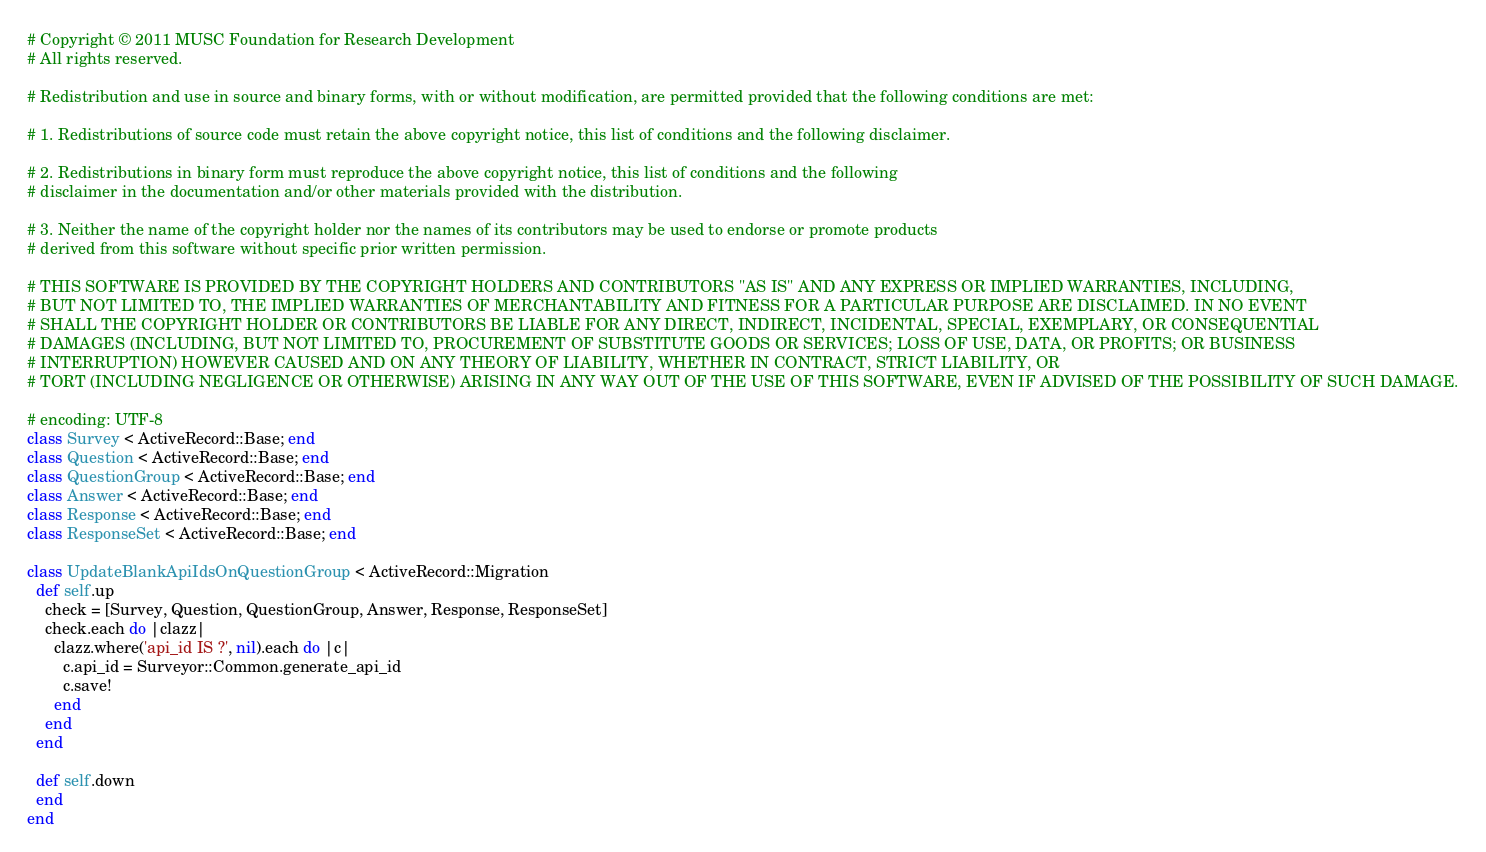<code> <loc_0><loc_0><loc_500><loc_500><_Ruby_># Copyright © 2011 MUSC Foundation for Research Development
# All rights reserved.

# Redistribution and use in source and binary forms, with or without modification, are permitted provided that the following conditions are met:

# 1. Redistributions of source code must retain the above copyright notice, this list of conditions and the following disclaimer.

# 2. Redistributions in binary form must reproduce the above copyright notice, this list of conditions and the following
# disclaimer in the documentation and/or other materials provided with the distribution.

# 3. Neither the name of the copyright holder nor the names of its contributors may be used to endorse or promote products
# derived from this software without specific prior written permission.

# THIS SOFTWARE IS PROVIDED BY THE COPYRIGHT HOLDERS AND CONTRIBUTORS "AS IS" AND ANY EXPRESS OR IMPLIED WARRANTIES, INCLUDING,
# BUT NOT LIMITED TO, THE IMPLIED WARRANTIES OF MERCHANTABILITY AND FITNESS FOR A PARTICULAR PURPOSE ARE DISCLAIMED. IN NO EVENT
# SHALL THE COPYRIGHT HOLDER OR CONTRIBUTORS BE LIABLE FOR ANY DIRECT, INDIRECT, INCIDENTAL, SPECIAL, EXEMPLARY, OR CONSEQUENTIAL
# DAMAGES (INCLUDING, BUT NOT LIMITED TO, PROCUREMENT OF SUBSTITUTE GOODS OR SERVICES; LOSS OF USE, DATA, OR PROFITS; OR BUSINESS
# INTERRUPTION) HOWEVER CAUSED AND ON ANY THEORY OF LIABILITY, WHETHER IN CONTRACT, STRICT LIABILITY, OR
# TORT (INCLUDING NEGLIGENCE OR OTHERWISE) ARISING IN ANY WAY OUT OF THE USE OF THIS SOFTWARE, EVEN IF ADVISED OF THE POSSIBILITY OF SUCH DAMAGE.

# encoding: UTF-8
class Survey < ActiveRecord::Base; end
class Question < ActiveRecord::Base; end
class QuestionGroup < ActiveRecord::Base; end
class Answer < ActiveRecord::Base; end
class Response < ActiveRecord::Base; end
class ResponseSet < ActiveRecord::Base; end

class UpdateBlankApiIdsOnQuestionGroup < ActiveRecord::Migration
  def self.up
    check = [Survey, Question, QuestionGroup, Answer, Response, ResponseSet]
    check.each do |clazz|
      clazz.where('api_id IS ?', nil).each do |c|
        c.api_id = Surveyor::Common.generate_api_id
        c.save!
      end
    end
  end

  def self.down
  end
end
</code> 